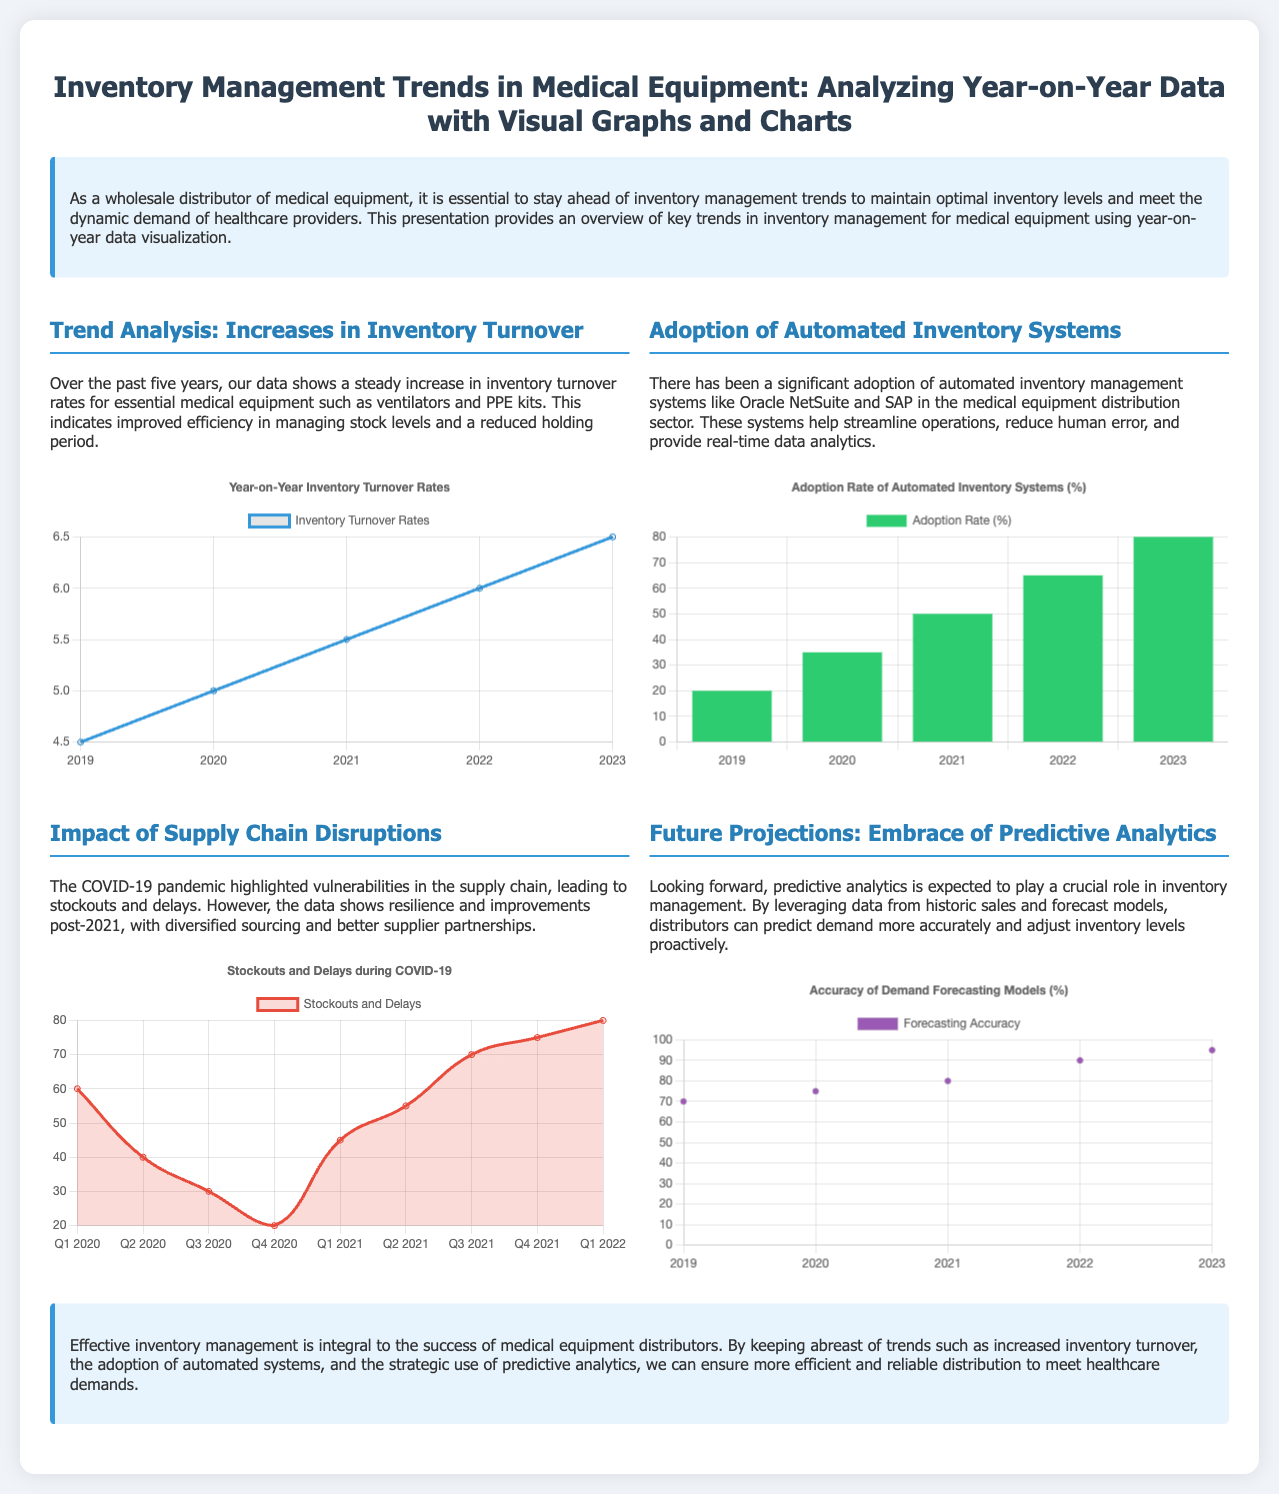What is the main focus of the presentation? The presentation focuses on the trends in inventory management for medical equipment and their analysis using year-on-year data.
Answer: Inventory Management Trends What year shows the highest inventory turnover rate? The inventory turnover rates are provided for five years, with 2023 showing the highest rate.
Answer: 6.5 What percentage of automated inventory systems was adopted in 2023? The document presents a bar chart showing the adoption rate of automated systems, with 2023 at 80%.
Answer: 80% How many quarters had stockouts and delays during COVID-19 according to the chart? The timeline provided in the chart spans from Q1 2020 to Q1 2022, thus includes 8 quarters.
Answer: 8 What is the trend in forecasting accuracy from 2019 to 2023? The scatter chart shows an increasing trend in forecasting accuracy, indicating improvements each year.
Answer: Increasing What impact did the COVID-19 pandemic have on inventory management? The document indicates that the pandemic highlighted vulnerabilities in the supply chain leading to stockouts and delays.
Answer: Vulnerabilities and stockouts What technology is cited as significant for streamlining operations? The section discusses the adoption of automated inventory management systems as significant technology.
Answer: Automated Inventory Systems What type of chart illustrates stockouts and delays? The presentation uses a line chart to visually represent stockouts and delays during COVID-19.
Answer: Line chart 